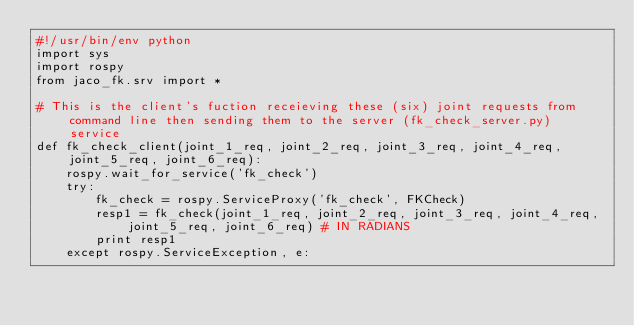<code> <loc_0><loc_0><loc_500><loc_500><_Python_>#!/usr/bin/env python
import sys
import rospy
from jaco_fk.srv import *

# This is the client's fuction receieving these (six) joint requests from command line then sending them to the server (fk_check_server.py) service
def fk_check_client(joint_1_req, joint_2_req, joint_3_req, joint_4_req, joint_5_req, joint_6_req):
    rospy.wait_for_service('fk_check')
    try:
        fk_check = rospy.ServiceProxy('fk_check', FKCheck)
        resp1 = fk_check(joint_1_req, joint_2_req, joint_3_req, joint_4_req, joint_5_req, joint_6_req) # IN RADIANS
        print resp1
    except rospy.ServiceException, e:</code> 